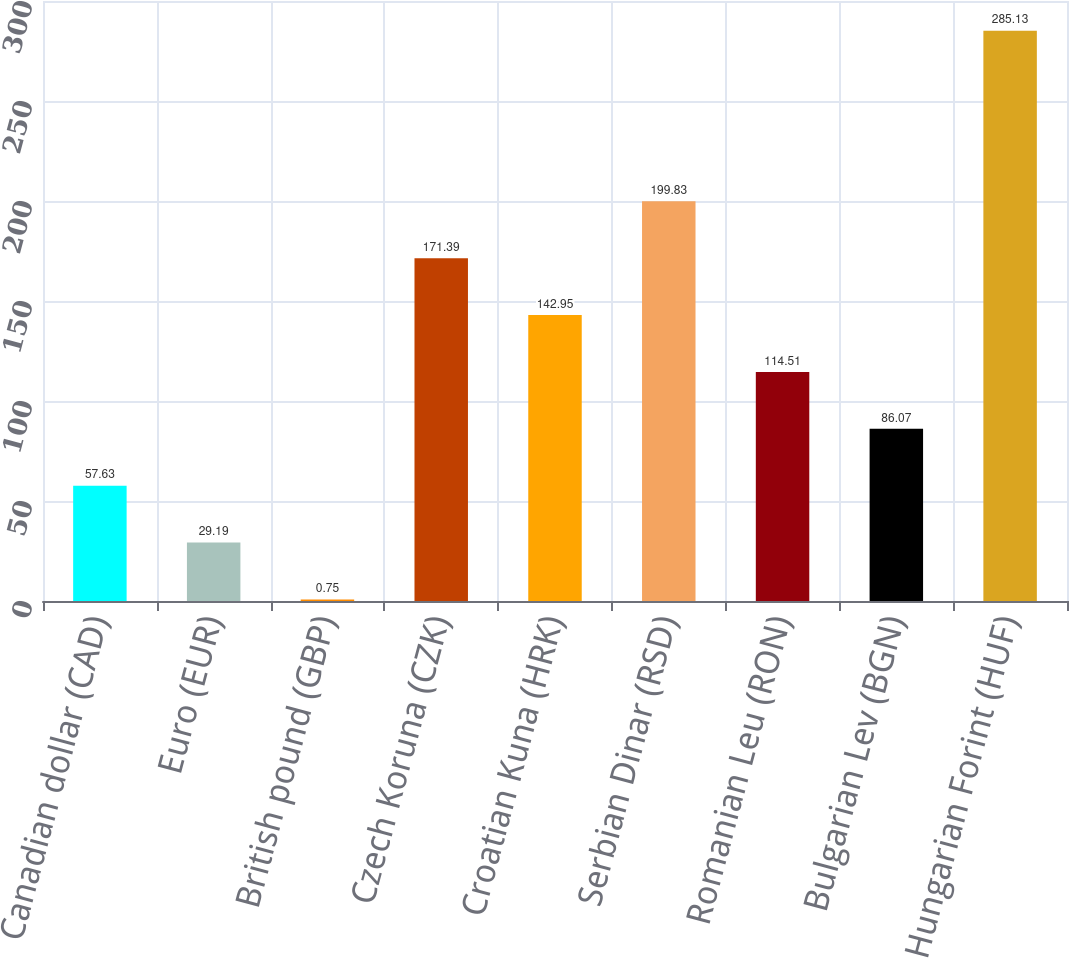<chart> <loc_0><loc_0><loc_500><loc_500><bar_chart><fcel>Canadian dollar (CAD)<fcel>Euro (EUR)<fcel>British pound (GBP)<fcel>Czech Koruna (CZK)<fcel>Croatian Kuna (HRK)<fcel>Serbian Dinar (RSD)<fcel>Romanian Leu (RON)<fcel>Bulgarian Lev (BGN)<fcel>Hungarian Forint (HUF)<nl><fcel>57.63<fcel>29.19<fcel>0.75<fcel>171.39<fcel>142.95<fcel>199.83<fcel>114.51<fcel>86.07<fcel>285.13<nl></chart> 